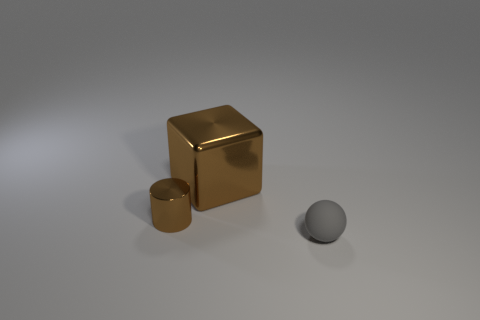What is the size of the metal cylinder that is the same color as the large metal object?
Your response must be concise. Small. Is there anything else that has the same size as the brown shiny cube?
Your response must be concise. No. What number of small metallic objects are the same color as the big metal object?
Offer a very short reply. 1. Are there the same number of tiny gray matte things behind the gray matte thing and gray objects that are in front of the big brown metal cube?
Your response must be concise. No. Is the gray rubber thing the same shape as the big metal object?
Keep it short and to the point. No. How many shiny things are either big cubes or small green balls?
Provide a succinct answer. 1. There is a large thing that is the same color as the small cylinder; what is it made of?
Your response must be concise. Metal. Is the size of the rubber ball the same as the brown metallic cylinder?
Your response must be concise. Yes. How many things are big gray matte cylinders or things that are in front of the brown metallic block?
Keep it short and to the point. 2. There is a brown thing that is the same size as the gray sphere; what is its material?
Make the answer very short. Metal. 